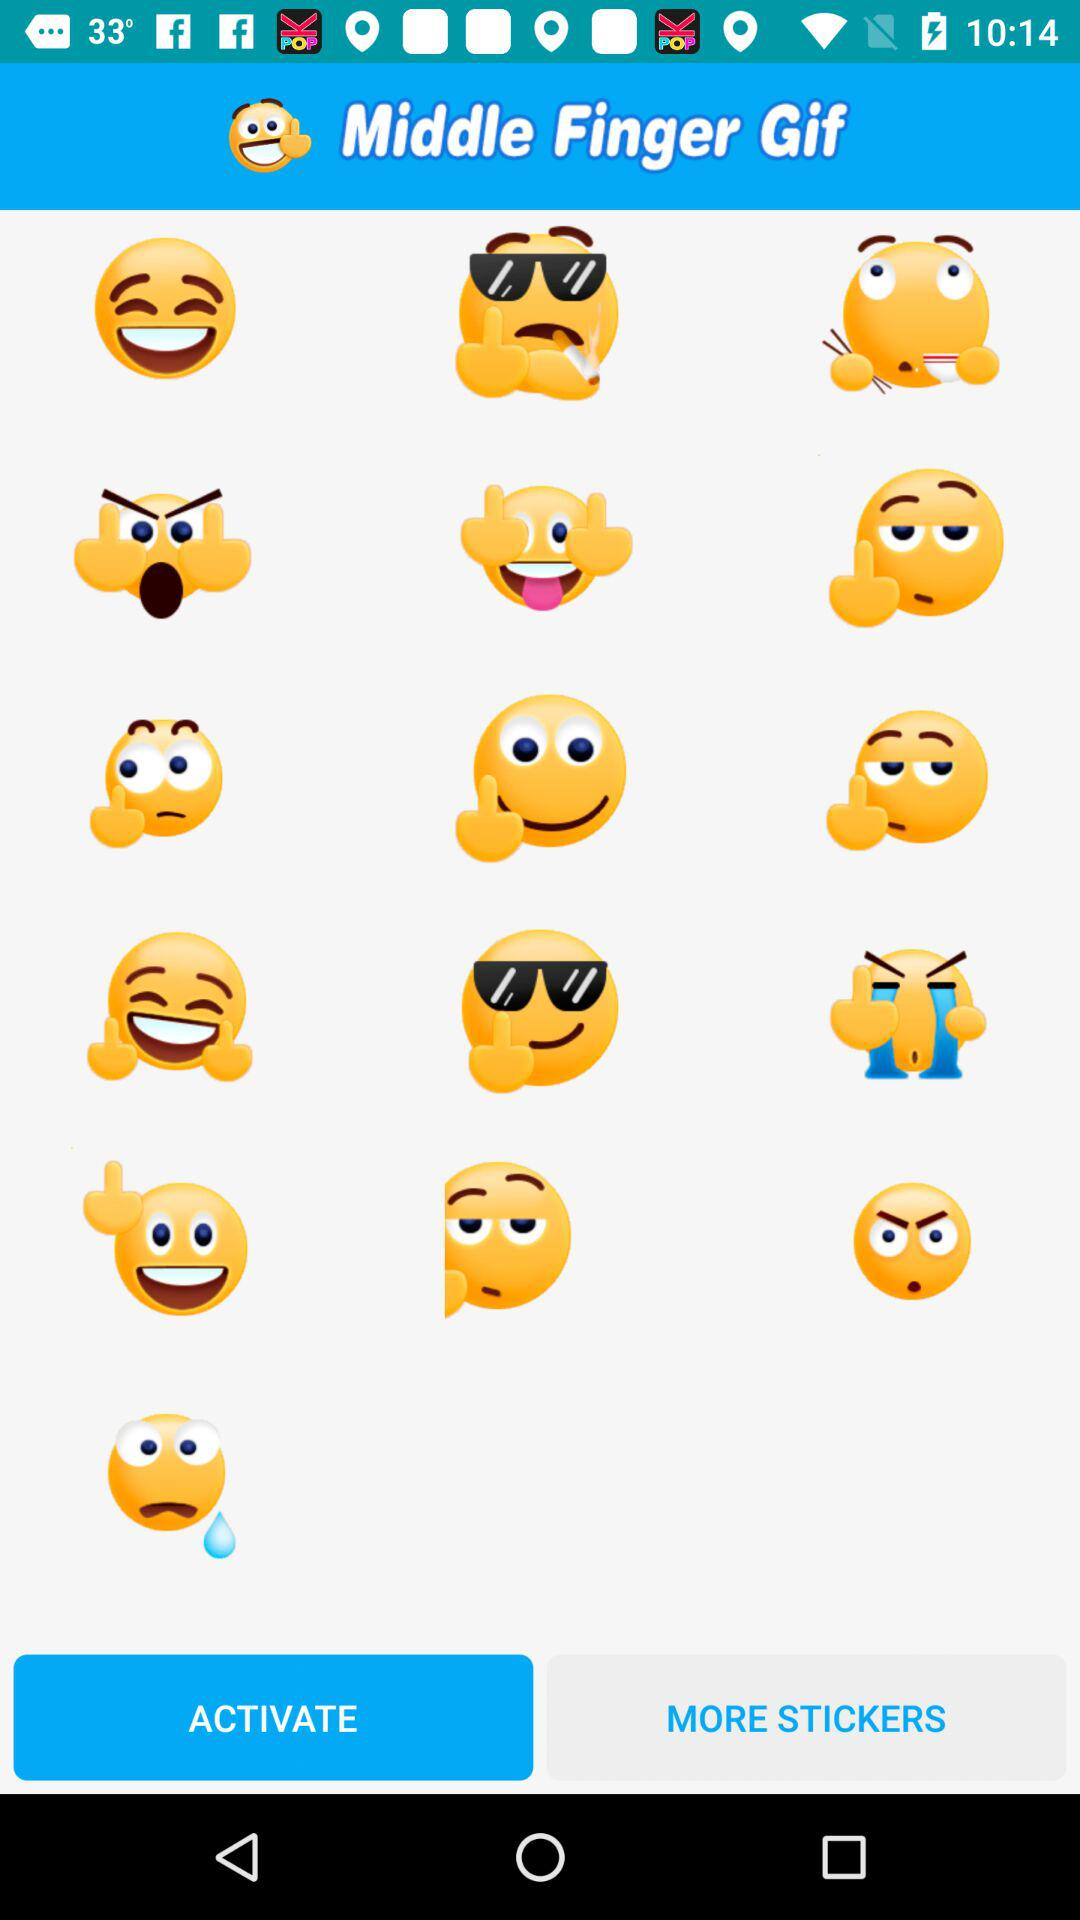How many smiley faces are there in the first row?
Answer the question using a single word or phrase. 3 